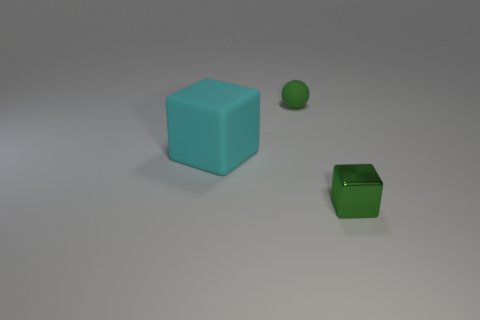Is there any other thing that is the same size as the cyan rubber object?
Your answer should be very brief. No. What number of other green rubber things are the same shape as the big object?
Offer a very short reply. 0. There is a object that is the same material as the ball; what is its size?
Provide a short and direct response. Large. Does the rubber block have the same size as the metal block?
Give a very brief answer. No. Are there any cyan metallic spheres?
Your answer should be very brief. No. What size is the ball that is the same color as the shiny block?
Provide a short and direct response. Small. How big is the green thing in front of the small thing that is behind the rubber cube behind the small metal thing?
Make the answer very short. Small. How many other objects have the same material as the cyan object?
Keep it short and to the point. 1. What number of green metallic objects are the same size as the rubber block?
Your response must be concise. 0. What material is the small object behind the object left of the tiny thing behind the metal object?
Give a very brief answer. Rubber. 